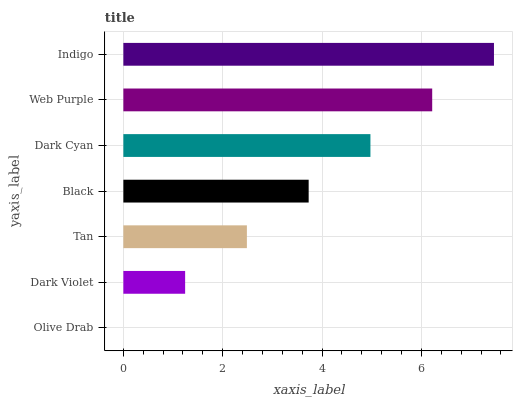Is Olive Drab the minimum?
Answer yes or no. Yes. Is Indigo the maximum?
Answer yes or no. Yes. Is Dark Violet the minimum?
Answer yes or no. No. Is Dark Violet the maximum?
Answer yes or no. No. Is Dark Violet greater than Olive Drab?
Answer yes or no. Yes. Is Olive Drab less than Dark Violet?
Answer yes or no. Yes. Is Olive Drab greater than Dark Violet?
Answer yes or no. No. Is Dark Violet less than Olive Drab?
Answer yes or no. No. Is Black the high median?
Answer yes or no. Yes. Is Black the low median?
Answer yes or no. Yes. Is Dark Cyan the high median?
Answer yes or no. No. Is Dark Cyan the low median?
Answer yes or no. No. 